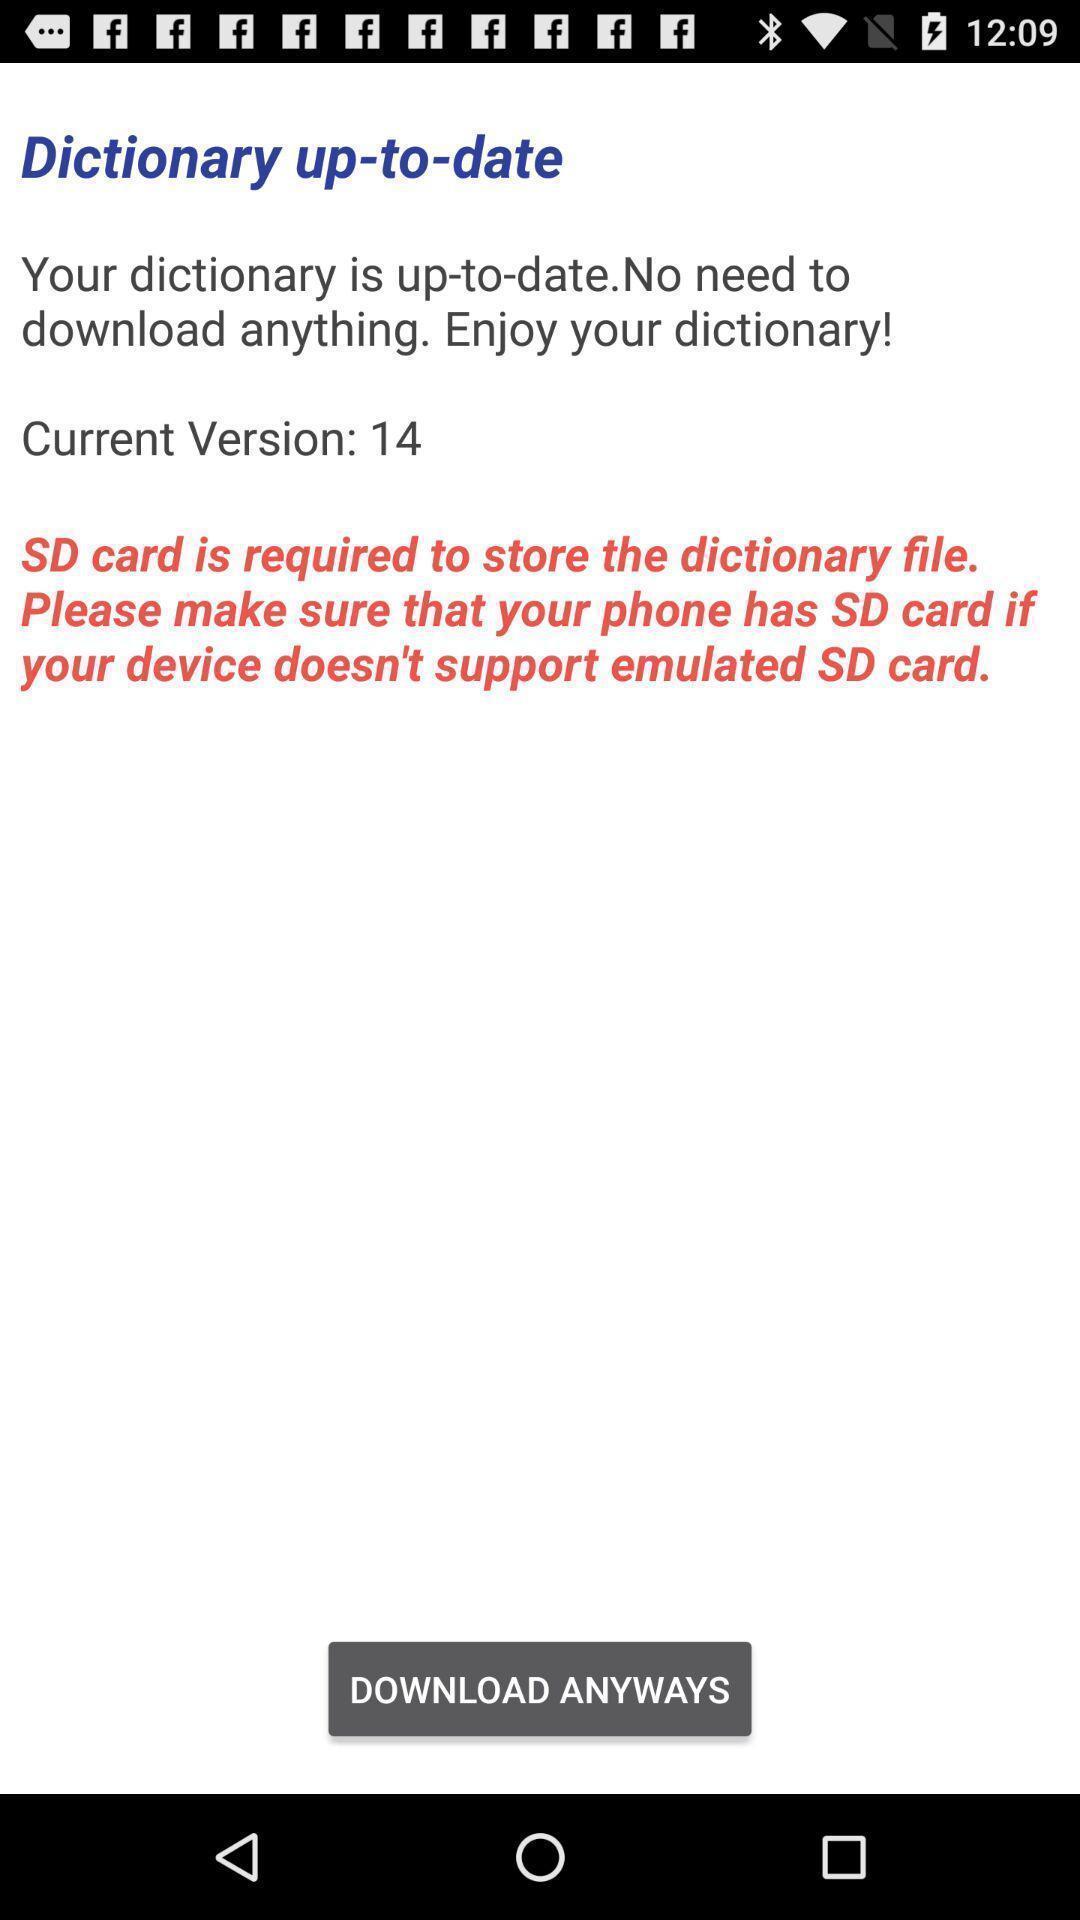Give me a summary of this screen capture. Screen shows update details. 